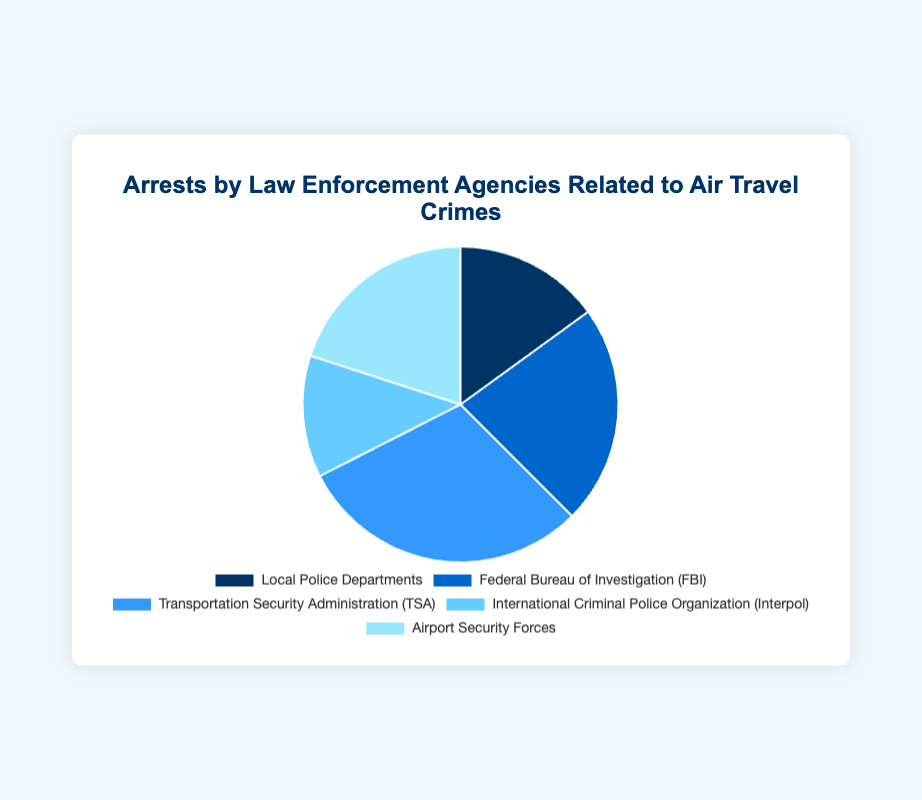Which agency has the highest number of arrests? The agency with the highest number of arrests is identified by the largest segment in the pie chart, which corresponds to the TSA with 60 arrests.
Answer: TSA How many more arrests did the TSA have compared to Interpol? The number of TSA arrests is 60, while Interpol has 25 arrests. Subtracting Interpol's arrests from TSA's gives 60 - 25 = 35.
Answer: 35 What's the total number of arrests made by Local Police Departments and Airport Security Forces? Add the arrests made by Local Police Departments (30) and Airport Security Forces (40): 30 + 40 = 70.
Answer: 70 Which two agencies together account for the smallest number of arrests? The two agencies with the smallest number of arrests are Local Police Departments (30) and Interpol (25). Adding these gives 30 + 25 = 55, the smallest combined.
Answer: Local Police Departments and Interpol What percentage of the total arrests were made by the FBI? First, sum up all the arrests to find the total: 30 (Local Police) + 45 (FBI) + 60 (TSA) + 25 (Interpol) + 40 (Airport Security) = 200. The FBI made 45 arrests, so the percentage is (45 / 200) * 100 = 22.5%.
Answer: 22.5% Which agency has the second largest number of arrests? By observing the chart, the second largest segment after TSA (60 arrests) belongs to the FBI, which has 45 arrests.
Answer: FBI How many fewer arrests did Local Police Departments make compared to Airport Security Forces? Local Police Departments made 30 arrests, and Airport Security Forces made 40 arrests. The difference is 40 - 30 = 10.
Answer: 10 Is the number of arrests by the TSA greater than the combined arrests of Local Police Departments and Interpol? TSA made 60 arrests. Local Police Departments and Interpol together made 30 + 25 = 55 arrests. 60 is greater than 55.
Answer: Yes What fraction of the total arrests were made by Airport Security Forces? The total number of arrests is 200. Airport Security Forces made 40 arrests. The fraction is 40 / 200 = 1/5.
Answer: 1/5 